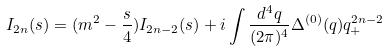<formula> <loc_0><loc_0><loc_500><loc_500>I _ { 2 n } ( s ) = ( m ^ { 2 } - \frac { s } { 4 } ) I _ { 2 n - 2 } ( s ) + i \int \frac { d ^ { 4 } q } { ( 2 \pi ) ^ { 4 } } \Delta ^ { ( 0 ) } ( q ) q _ { + } ^ { 2 n - 2 }</formula> 